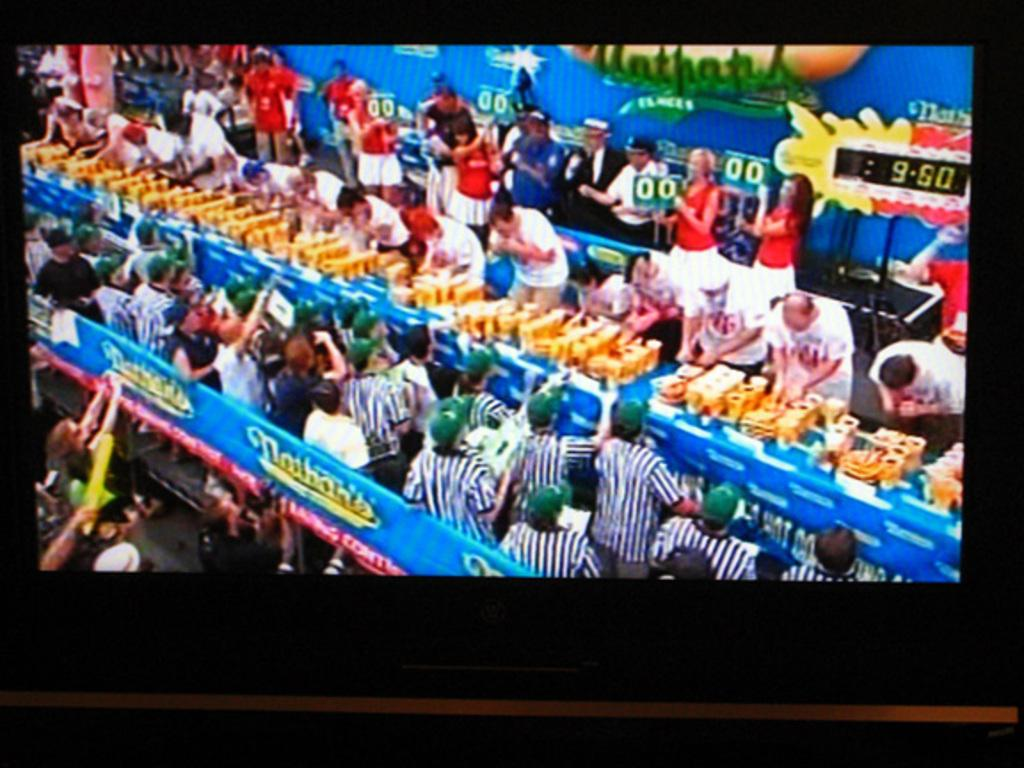<image>
Summarize the visual content of the image. TV displaying Nathans hot dog eating contest with 9:50 remaining. 